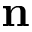<formula> <loc_0><loc_0><loc_500><loc_500>n</formula> 